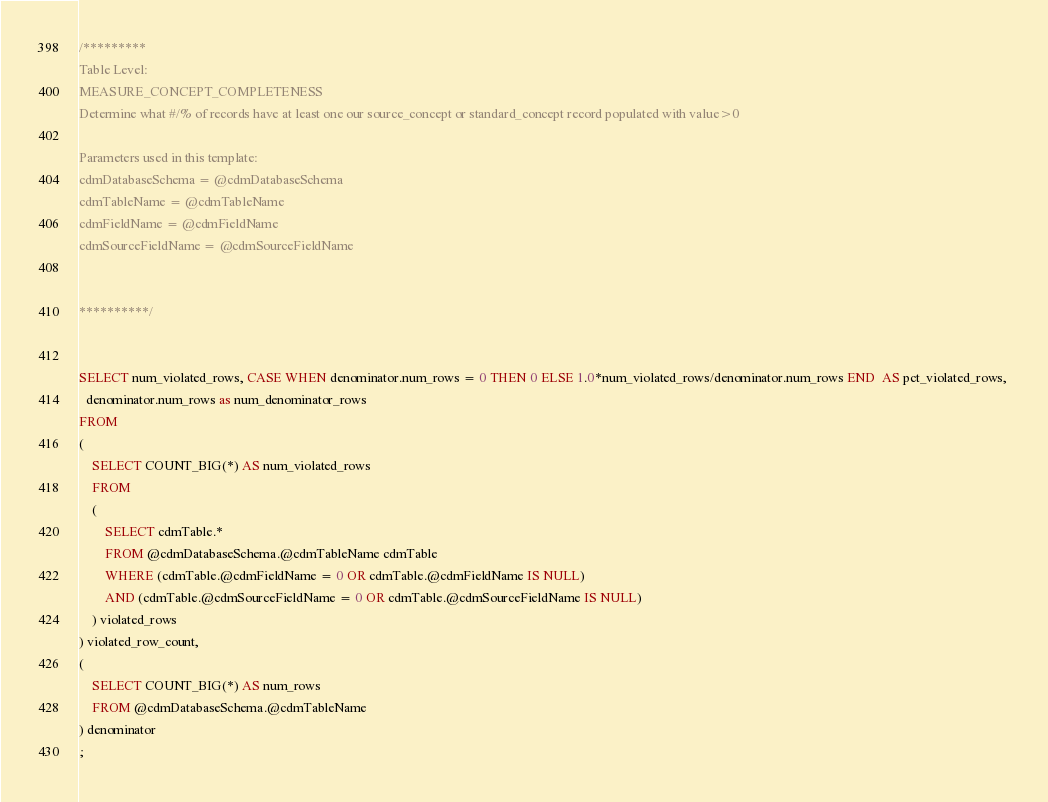<code> <loc_0><loc_0><loc_500><loc_500><_SQL_>
/*********
Table Level:  
MEASURE_CONCEPT_COMPLETENESS
Determine what #/% of records have at least one our source_concept or standard_concept record populated with value>0

Parameters used in this template:
cdmDatabaseSchema = @cdmDatabaseSchema
cdmTableName = @cdmTableName
cdmFieldName = @cdmFieldName
cdmSourceFieldName = @cdmSourceFieldName


**********/


SELECT num_violated_rows, CASE WHEN denominator.num_rows = 0 THEN 0 ELSE 1.0*num_violated_rows/denominator.num_rows END  AS pct_violated_rows, 
  denominator.num_rows as num_denominator_rows
FROM
(
	SELECT COUNT_BIG(*) AS num_violated_rows
	FROM
	(
		SELECT cdmTable.* 
		FROM @cdmDatabaseSchema.@cdmTableName cdmTable
		WHERE (cdmTable.@cdmFieldName = 0 OR cdmTable.@cdmFieldName IS NULL)
		AND (cdmTable.@cdmSourceFieldName = 0 OR cdmTable.@cdmSourceFieldName IS NULL)
	) violated_rows
) violated_row_count,
( 
	SELECT COUNT_BIG(*) AS num_rows
	FROM @cdmDatabaseSchema.@cdmTableName
) denominator
;</code> 